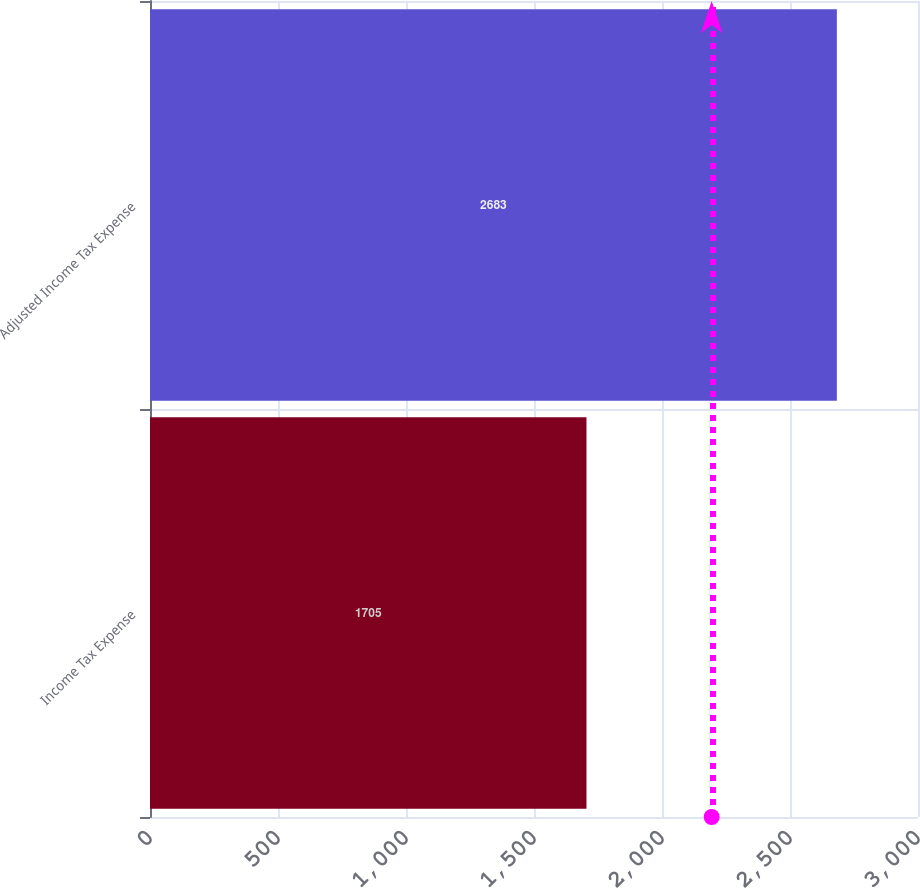Convert chart. <chart><loc_0><loc_0><loc_500><loc_500><bar_chart><fcel>Income Tax Expense<fcel>Adjusted Income Tax Expense<nl><fcel>1705<fcel>2683<nl></chart> 